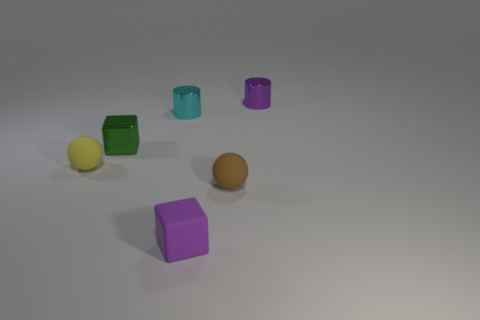Add 1 small cyan things. How many objects exist? 7 Subtract all cylinders. How many objects are left? 4 Subtract all tiny balls. Subtract all green blocks. How many objects are left? 3 Add 1 yellow balls. How many yellow balls are left? 2 Add 4 tiny rubber cubes. How many tiny rubber cubes exist? 5 Subtract 0 blue blocks. How many objects are left? 6 